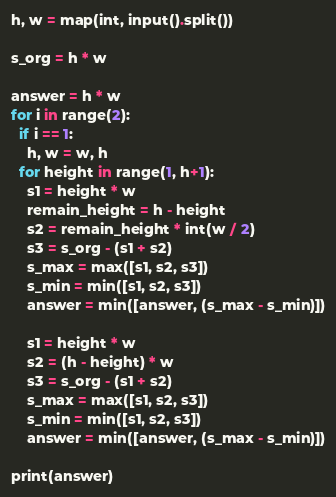Convert code to text. <code><loc_0><loc_0><loc_500><loc_500><_Python_>h, w = map(int, input().split())

s_org = h * w

answer = h * w
for i in range(2):
  if i == 1:
    h, w = w, h
  for height in range(1, h+1):
    s1 = height * w
    remain_height = h - height
    s2 = remain_height * int(w / 2)
    s3 = s_org - (s1 + s2)
    s_max = max([s1, s2, s3])
    s_min = min([s1, s2, s3])
    answer = min([answer, (s_max - s_min)])

    s1 = height * w
    s2 = (h - height) * w
    s3 = s_org - (s1 + s2)
    s_max = max([s1, s2, s3])
    s_min = min([s1, s2, s3])
    answer = min([answer, (s_max - s_min)])
  
print(answer)</code> 